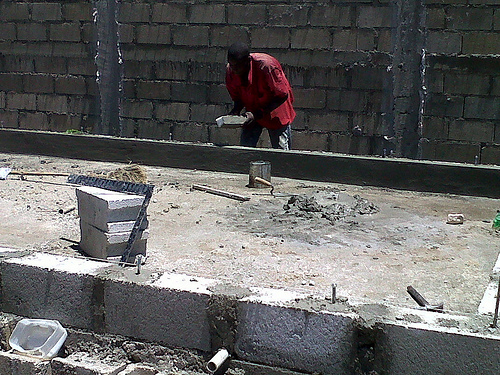<image>
Is the man above the brick? Yes. The man is positioned above the brick in the vertical space, higher up in the scene. 